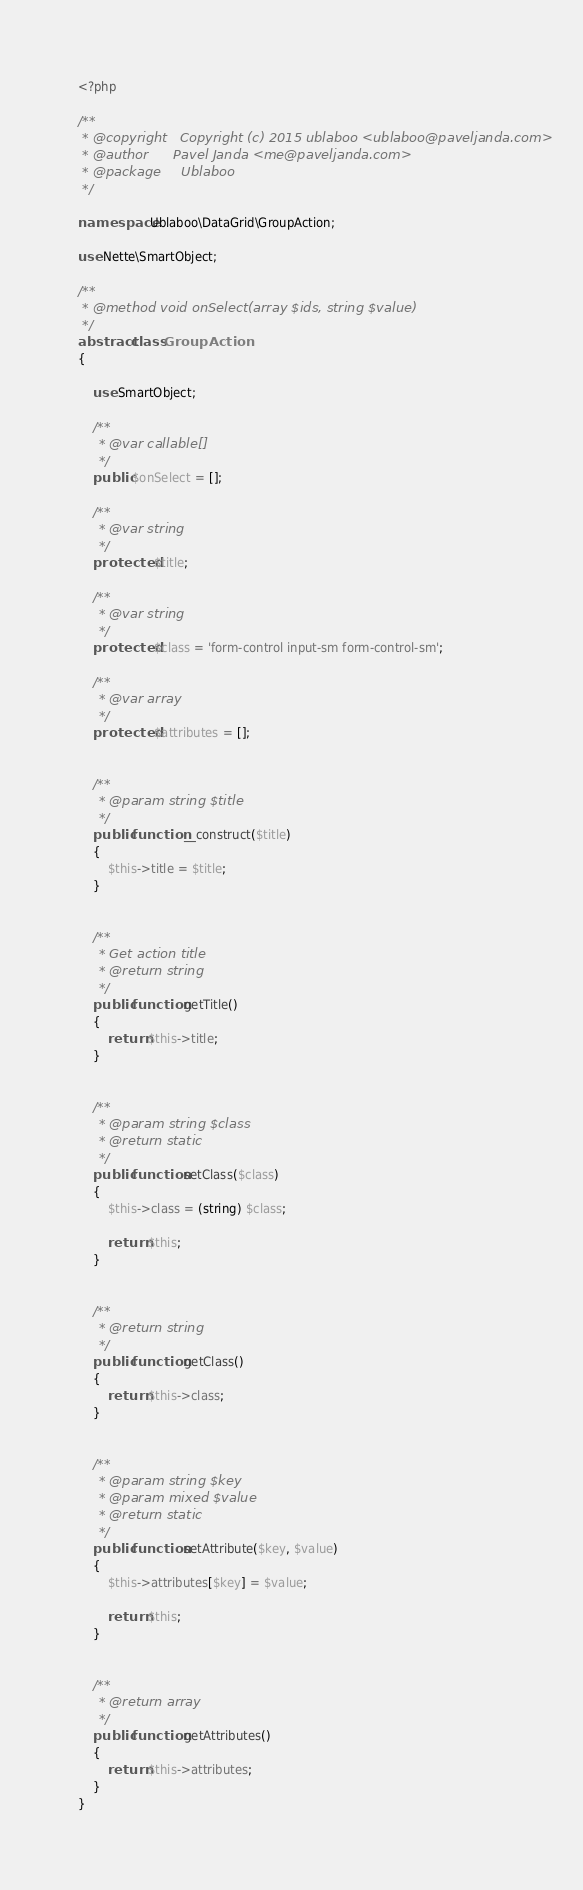<code> <loc_0><loc_0><loc_500><loc_500><_PHP_><?php

/**
 * @copyright   Copyright (c) 2015 ublaboo <ublaboo@paveljanda.com>
 * @author      Pavel Janda <me@paveljanda.com>
 * @package     Ublaboo
 */

namespace Ublaboo\DataGrid\GroupAction;

use Nette\SmartObject;

/**
 * @method void onSelect(array $ids, string $value)
 */
abstract class GroupAction
{

	use SmartObject;

	/**
	 * @var callable[]
	 */
	public $onSelect = [];

	/**
	 * @var string
	 */
	protected $title;

	/**
	 * @var string
	 */
	protected $class = 'form-control input-sm form-control-sm';

	/**
	 * @var array
	 */
	protected $attributes = [];


	/**
	 * @param string $title
	 */
	public function __construct($title)
	{
		$this->title = $title;
	}


	/**
	 * Get action title
	 * @return string
	 */
	public function getTitle()
	{
		return $this->title;
	}


	/**
	 * @param string $class
	 * @return static
	 */
	public function setClass($class)
	{
		$this->class = (string) $class;

		return $this;
	}


	/**
	 * @return string
	 */
	public function getClass()
	{
		return $this->class;
	}


	/**
	 * @param string $key
	 * @param mixed $value
	 * @return static
	 */
	public function setAttribute($key, $value)
	{
		$this->attributes[$key] = $value;

		return $this;
	}


	/**
	 * @return array
	 */
	public function getAttributes()
	{
		return $this->attributes;
	}
}
</code> 